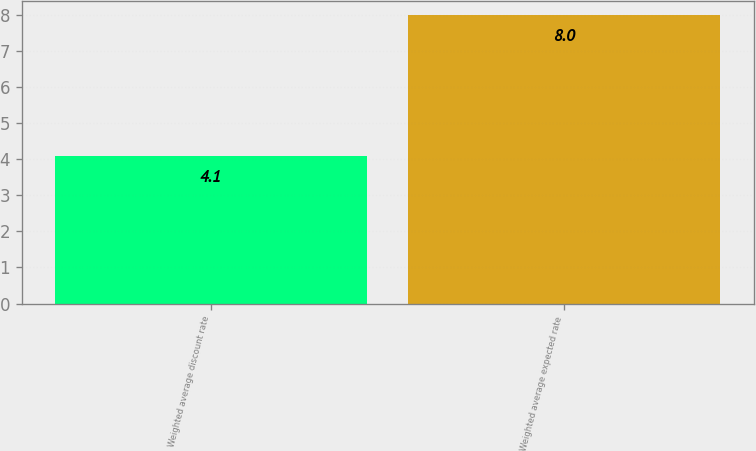Convert chart. <chart><loc_0><loc_0><loc_500><loc_500><bar_chart><fcel>Weighted average discount rate<fcel>Weighted average expected rate<nl><fcel>4.1<fcel>8<nl></chart> 